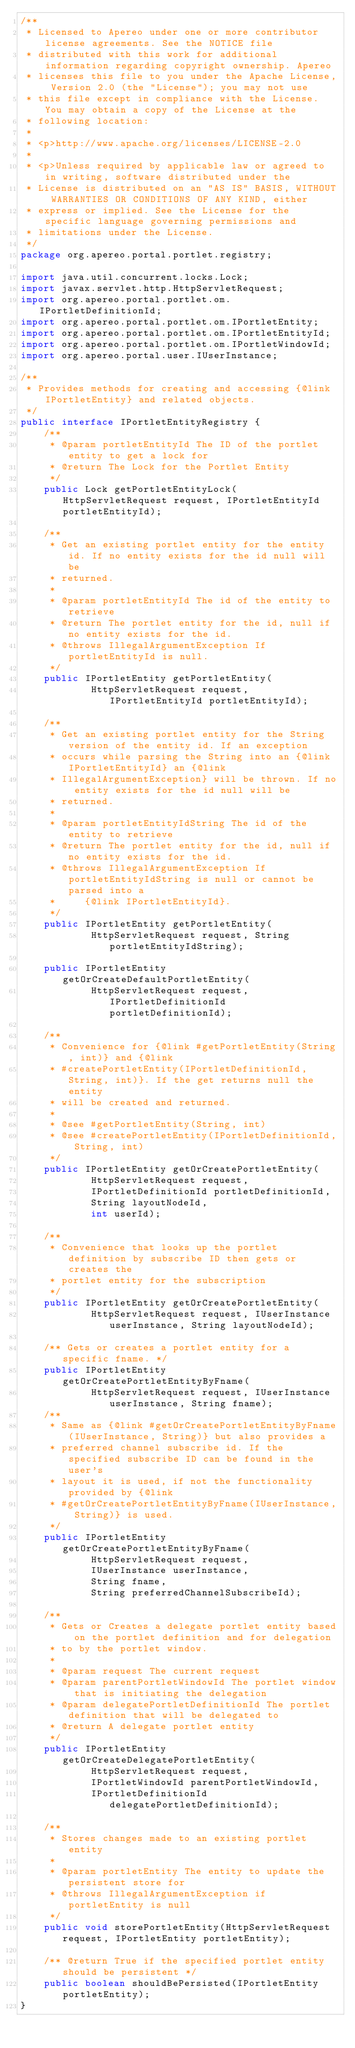Convert code to text. <code><loc_0><loc_0><loc_500><loc_500><_Java_>/**
 * Licensed to Apereo under one or more contributor license agreements. See the NOTICE file
 * distributed with this work for additional information regarding copyright ownership. Apereo
 * licenses this file to you under the Apache License, Version 2.0 (the "License"); you may not use
 * this file except in compliance with the License. You may obtain a copy of the License at the
 * following location:
 *
 * <p>http://www.apache.org/licenses/LICENSE-2.0
 *
 * <p>Unless required by applicable law or agreed to in writing, software distributed under the
 * License is distributed on an "AS IS" BASIS, WITHOUT WARRANTIES OR CONDITIONS OF ANY KIND, either
 * express or implied. See the License for the specific language governing permissions and
 * limitations under the License.
 */
package org.apereo.portal.portlet.registry;

import java.util.concurrent.locks.Lock;
import javax.servlet.http.HttpServletRequest;
import org.apereo.portal.portlet.om.IPortletDefinitionId;
import org.apereo.portal.portlet.om.IPortletEntity;
import org.apereo.portal.portlet.om.IPortletEntityId;
import org.apereo.portal.portlet.om.IPortletWindowId;
import org.apereo.portal.user.IUserInstance;

/**
 * Provides methods for creating and accessing {@link IPortletEntity} and related objects.
 */
public interface IPortletEntityRegistry {
    /**
     * @param portletEntityId The ID of the portlet entity to get a lock for
     * @return The Lock for the Portlet Entity
     */
    public Lock getPortletEntityLock(HttpServletRequest request, IPortletEntityId portletEntityId);

    /**
     * Get an existing portlet entity for the entity id. If no entity exists for the id null will be
     * returned.
     *
     * @param portletEntityId The id of the entity to retrieve
     * @return The portlet entity for the id, null if no entity exists for the id.
     * @throws IllegalArgumentException If portletEntityId is null.
     */
    public IPortletEntity getPortletEntity(
            HttpServletRequest request, IPortletEntityId portletEntityId);

    /**
     * Get an existing portlet entity for the String version of the entity id. If an exception
     * occurs while parsing the String into an {@link IPortletEntityId} an {@link
     * IllegalArgumentException} will be thrown. If no entity exists for the id null will be
     * returned.
     *
     * @param portletEntityIdString The id of the entity to retrieve
     * @return The portlet entity for the id, null if no entity exists for the id.
     * @throws IllegalArgumentException If portletEntityIdString is null or cannot be parsed into a
     *     {@link IPortletEntityId}.
     */
    public IPortletEntity getPortletEntity(
            HttpServletRequest request, String portletEntityIdString);

    public IPortletEntity getOrCreateDefaultPortletEntity(
            HttpServletRequest request, IPortletDefinitionId portletDefinitionId);

    /**
     * Convenience for {@link #getPortletEntity(String, int)} and {@link
     * #createPortletEntity(IPortletDefinitionId, String, int)}. If the get returns null the entity
     * will be created and returned.
     *
     * @see #getPortletEntity(String, int)
     * @see #createPortletEntity(IPortletDefinitionId, String, int)
     */
    public IPortletEntity getOrCreatePortletEntity(
            HttpServletRequest request,
            IPortletDefinitionId portletDefinitionId,
            String layoutNodeId,
            int userId);

    /**
     * Convenience that looks up the portlet definition by subscribe ID then gets or creates the
     * portlet entity for the subscription
     */
    public IPortletEntity getOrCreatePortletEntity(
            HttpServletRequest request, IUserInstance userInstance, String layoutNodeId);

    /** Gets or creates a portlet entity for a specific fname. */
    public IPortletEntity getOrCreatePortletEntityByFname(
            HttpServletRequest request, IUserInstance userInstance, String fname);
    /**
     * Same as {@link #getOrCreatePortletEntityByFname(IUserInstance, String)} but also provides a
     * preferred channel subscribe id. If the specified subscribe ID can be found in the user's
     * layout it is used, if not the functionality provided by {@link
     * #getOrCreatePortletEntityByFname(IUserInstance, String)} is used.
     */
    public IPortletEntity getOrCreatePortletEntityByFname(
            HttpServletRequest request,
            IUserInstance userInstance,
            String fname,
            String preferredChannelSubscribeId);

    /**
     * Gets or Creates a delegate portlet entity based on the portlet definition and for delegation
     * to by the portlet window.
     *
     * @param request The current request
     * @param parentPortletWindowId The portlet window that is initiating the delegation
     * @param delegatePortletDefinitionId The portlet definition that will be delegated to
     * @return A delegate portlet entity
     */
    public IPortletEntity getOrCreateDelegatePortletEntity(
            HttpServletRequest request,
            IPortletWindowId parentPortletWindowId,
            IPortletDefinitionId delegatePortletDefinitionId);

    /**
     * Stores changes made to an existing portlet entity
     *
     * @param portletEntity The entity to update the persistent store for
     * @throws IllegalArgumentException if portletEntity is null
     */
    public void storePortletEntity(HttpServletRequest request, IPortletEntity portletEntity);

    /** @return True if the specified portlet entity should be persistent */
    public boolean shouldBePersisted(IPortletEntity portletEntity);
}
</code> 